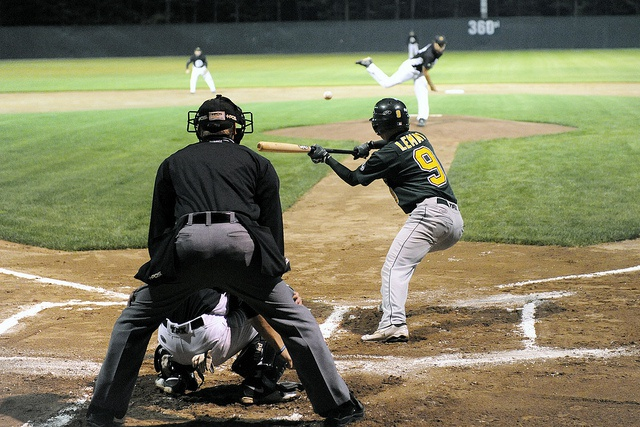Describe the objects in this image and their specific colors. I can see people in black, gray, and olive tones, people in black, lightgray, darkgray, and gray tones, people in black, gray, lavender, and darkgray tones, people in black, white, gray, and darkgray tones, and people in black, white, khaki, gray, and darkgray tones in this image. 